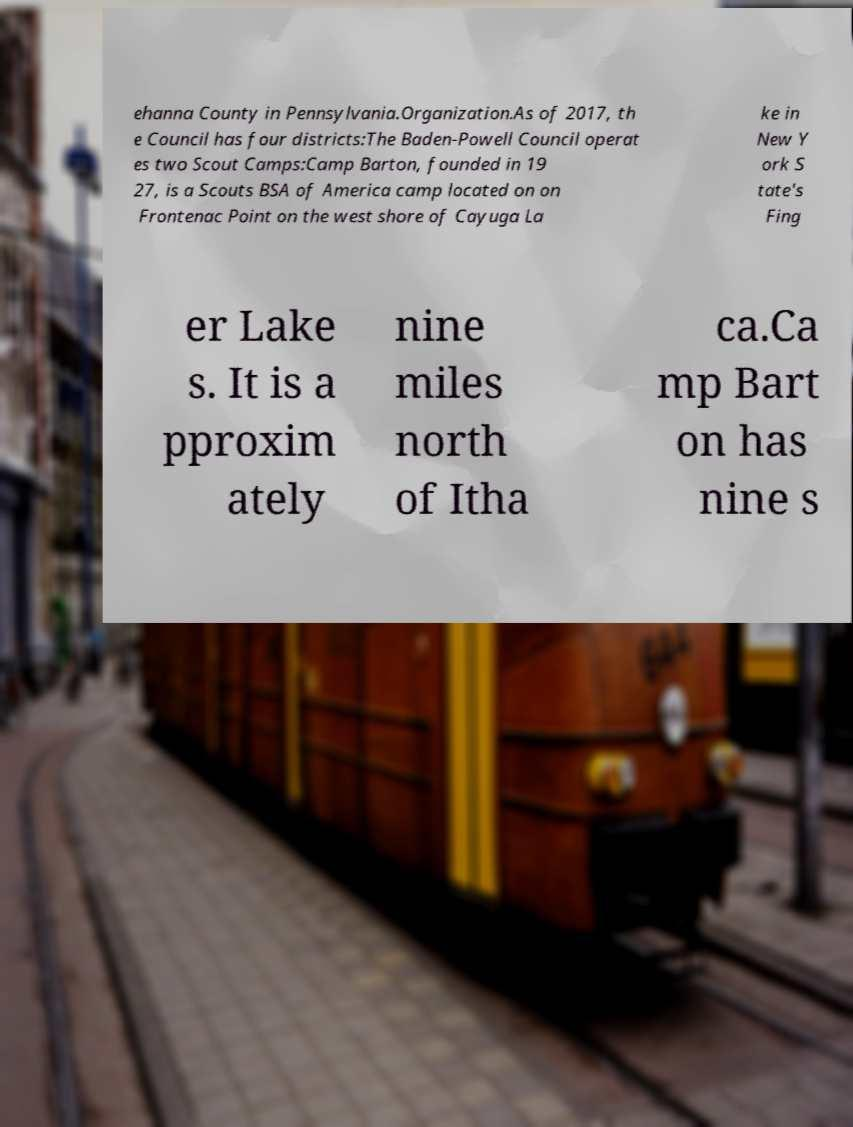What messages or text are displayed in this image? I need them in a readable, typed format. ehanna County in Pennsylvania.Organization.As of 2017, th e Council has four districts:The Baden-Powell Council operat es two Scout Camps:Camp Barton, founded in 19 27, is a Scouts BSA of America camp located on on Frontenac Point on the west shore of Cayuga La ke in New Y ork S tate's Fing er Lake s. It is a pproxim ately nine miles north of Itha ca.Ca mp Bart on has nine s 